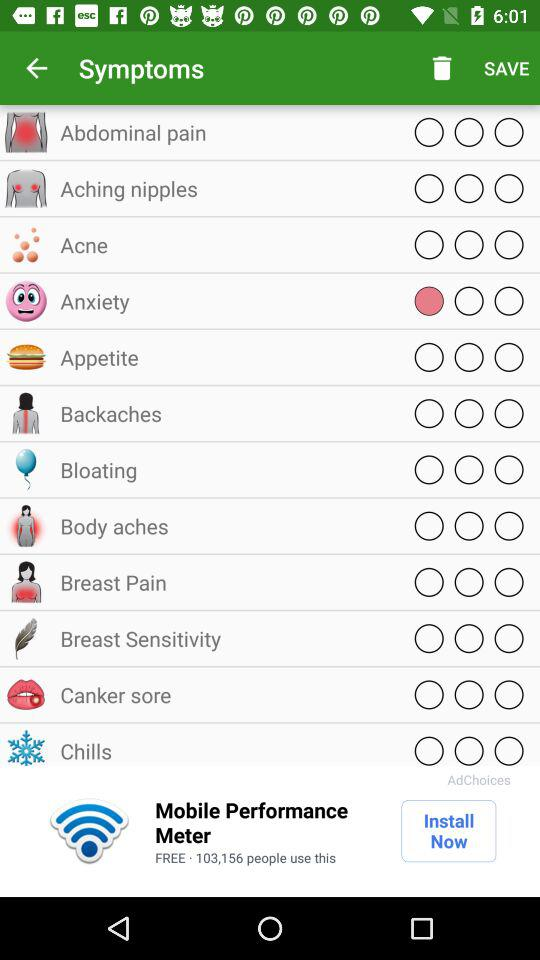What are the available symptoms? The available symptoms are abdominal pain, aching nipples, acne, anxiety, appetite, backaches, bloating, body aches, breast pain, breast sensitivity, canker sore and chills. 